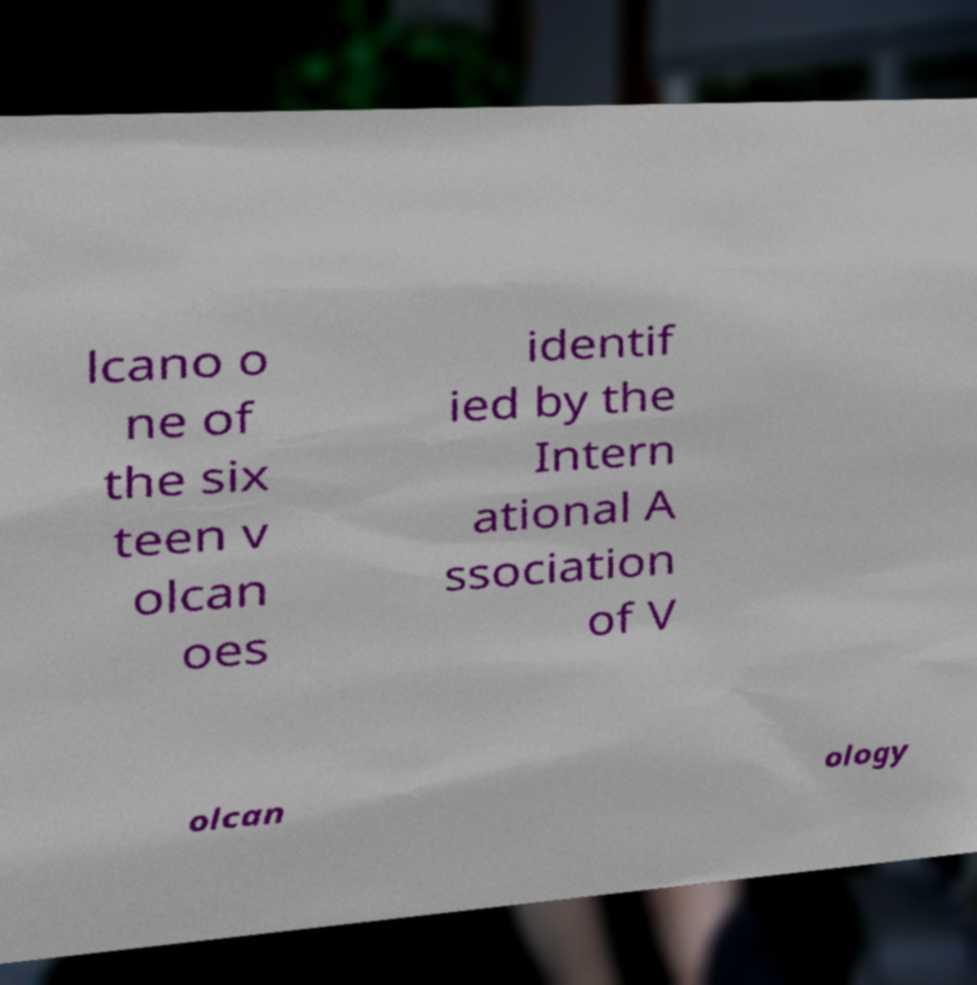There's text embedded in this image that I need extracted. Can you transcribe it verbatim? lcano o ne of the six teen v olcan oes identif ied by the Intern ational A ssociation of V olcan ology 